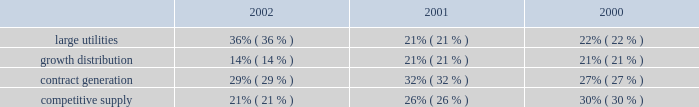Competitive supply aes 2019s competitive supply line of business consists of generating facilities that sell electricity directly to wholesale customers in competitive markets .
Additionally , as compared to the contract generation segment discussed above , these generating facilities generally sell less than 75% ( 75 % ) of their output pursuant to long-term contracts with pre-determined pricing provisions and/or sell into power pools , under shorter-term contracts or into daily spot markets .
The prices paid for electricity under short-term contracts and in the spot markets are unpredictable and can be , and from time to time have been , volatile .
The results of operations of aes 2019s competitive supply business are also more sensitive to the impact of market fluctuations in the price of electricity , natural gas , coal and other raw materials .
In the united kingdom , txu europe entered administration in november 2002 and is no longer performing under its contracts with drax and barry .
As described in the footnotes and in other sections of the discussion and analysis of financial condition and results of operations , txu europe 2019s failure to perform under its contracts has had a material adverse effect on the results of operations of these businesses .
Two aes competitive supply businesses , aes wolf hollow , l.p .
And granite ridge have fuel supply agreements with el paso merchant energy l.p .
An affiliate of el paso corp. , which has encountered financial difficulties .
The company does not believe the financial difficulties of el paso corp .
Will have a material adverse effect on el paso merchant energy l.p . 2019s performance under the supply agreement ; however , there can be no assurance that a further deterioration in el paso corp 2019s financial condition will not have a material adverse effect on the ability of el paso merchant energy l.p .
To perform its obligations .
While el paso corp 2019s financial condition may not have a material adverse effect on el paso merchant energy , l.p .
At this time , it could lead to a default under the aes wolf hollow , l.p . 2019s fuel supply agreement , in which case aes wolf hollow , l.p . 2019s lenders may seek to declare a default under its credit agreements .
Aes wolf hollow , l.p .
Is working in concert with its lenders to explore options to avoid such a default .
The revenues from our facilities that distribute electricity to end-use customers are generally subject to regulation .
These businesses are generally required to obtain third party approval or confirmation of rate increases before they can be passed on to the customers through tariffs .
These businesses comprise the large utilities and growth distribution segments of the company .
Revenues from contract generation and competitive supply are not regulated .
The distribution of revenues between the segments for the years ended december 31 , 2002 , 2001 and 2000 is as follows: .
Development costs certain subsidiaries and affiliates of the company ( domestic and non-u.s. ) are in various stages of developing and constructing greenfield power plants , some but not all of which have signed long-term contracts or made similar arrangements for the sale of electricity .
Successful completion depends upon overcoming substantial risks , including , but not limited to , risks relating to failures of siting , financing , construction , permitting , governmental approvals or the potential for termination of the power sales contract as a result of a failure to meet certain milestones .
As of december 31 , 2002 , capitalized costs for projects under development and in early stage construction were approximately $ 15 million and capitalized costs for projects under construction were approximately $ 3.2 billion .
The company believes .
What was the change in the large utilities percentage of revenues from 2001 to 2002? 
Computations: (36% - 21%)
Answer: 0.15. 